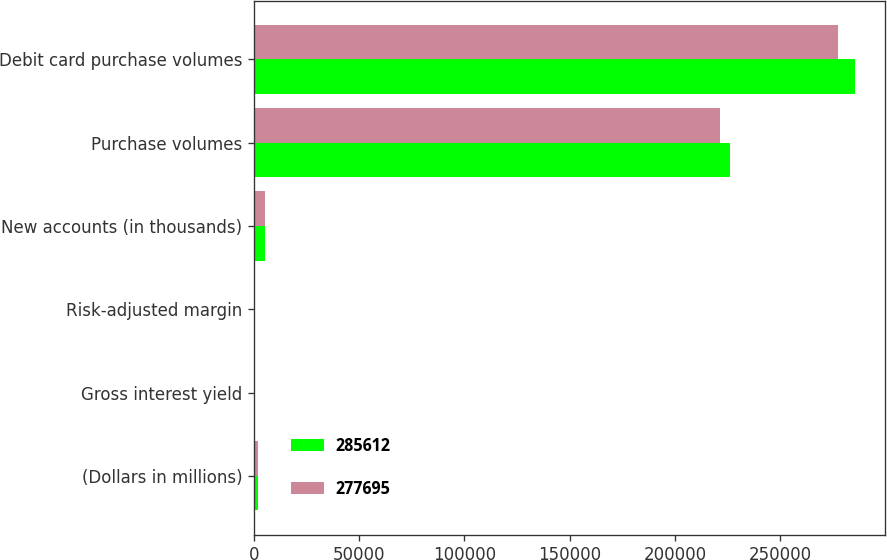Convert chart to OTSL. <chart><loc_0><loc_0><loc_500><loc_500><stacked_bar_chart><ecel><fcel>(Dollars in millions)<fcel>Gross interest yield<fcel>Risk-adjusted margin<fcel>New accounts (in thousands)<fcel>Purchase volumes<fcel>Debit card purchase volumes<nl><fcel>285612<fcel>2016<fcel>9.29<fcel>9.04<fcel>4979<fcel>226432<fcel>285612<nl><fcel>277695<fcel>2015<fcel>9.16<fcel>9.31<fcel>4973<fcel>221378<fcel>277695<nl></chart> 